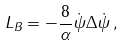Convert formula to latex. <formula><loc_0><loc_0><loc_500><loc_500>L _ { B } = - \frac { 8 } { \alpha } \dot { \psi } \Delta \dot { \psi } \, ,</formula> 